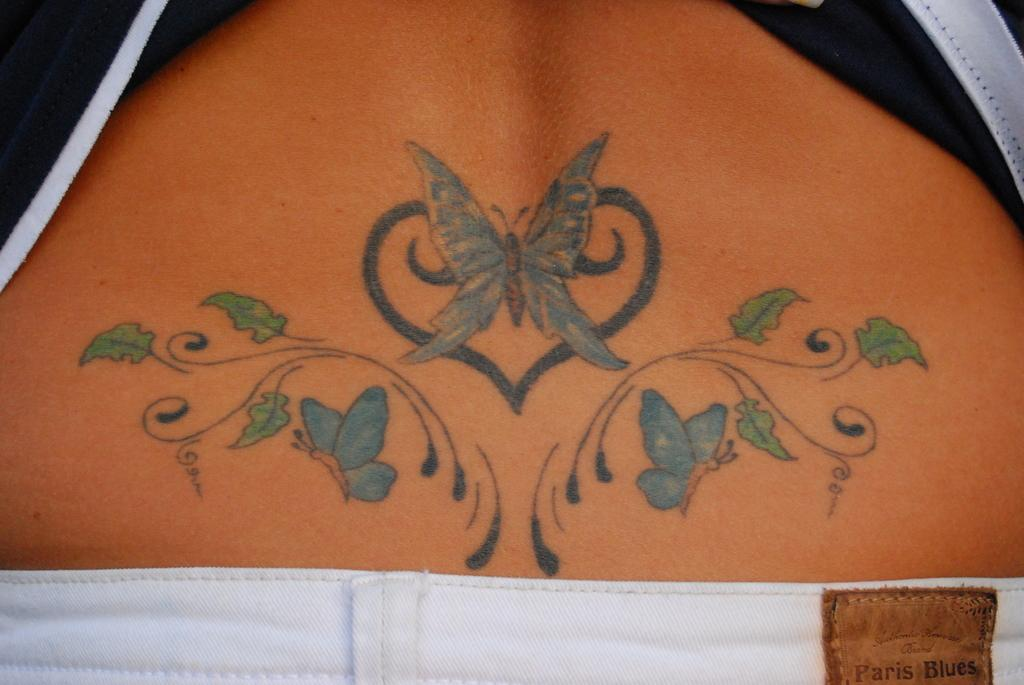What is the main subject of the image? There is a person in the image. What can be seen on the person's back? The person's back is painted with butterflies and flowers. What type of clothing is the person wearing on their upper body? The person is wearing a t-shirt. What type of clothing is the person wearing on their lower body? The person is wearing trousers. What type of love is the person expressing in the image? There is no indication of love or any emotion in the image; it only shows a person with a painted back and wearing a t-shirt and trousers. What government policy is being discussed in the image? There is no discussion or reference to any government policy in the image. 